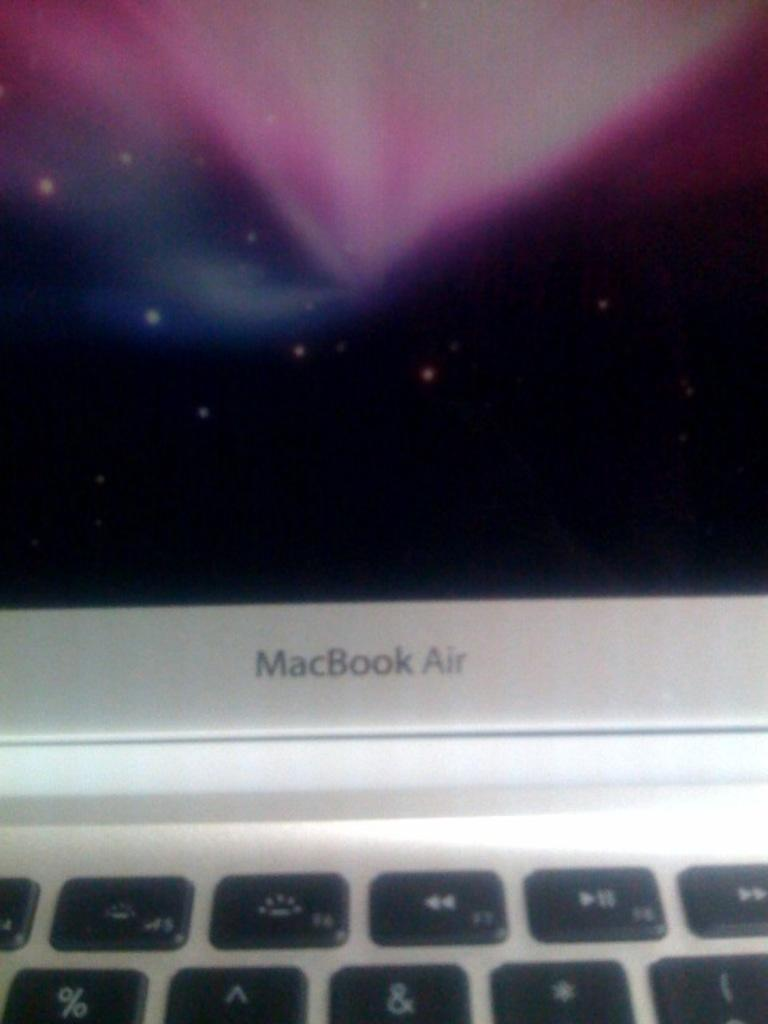<image>
Offer a succinct explanation of the picture presented. A close up of a Macbook Air laptop computer. 